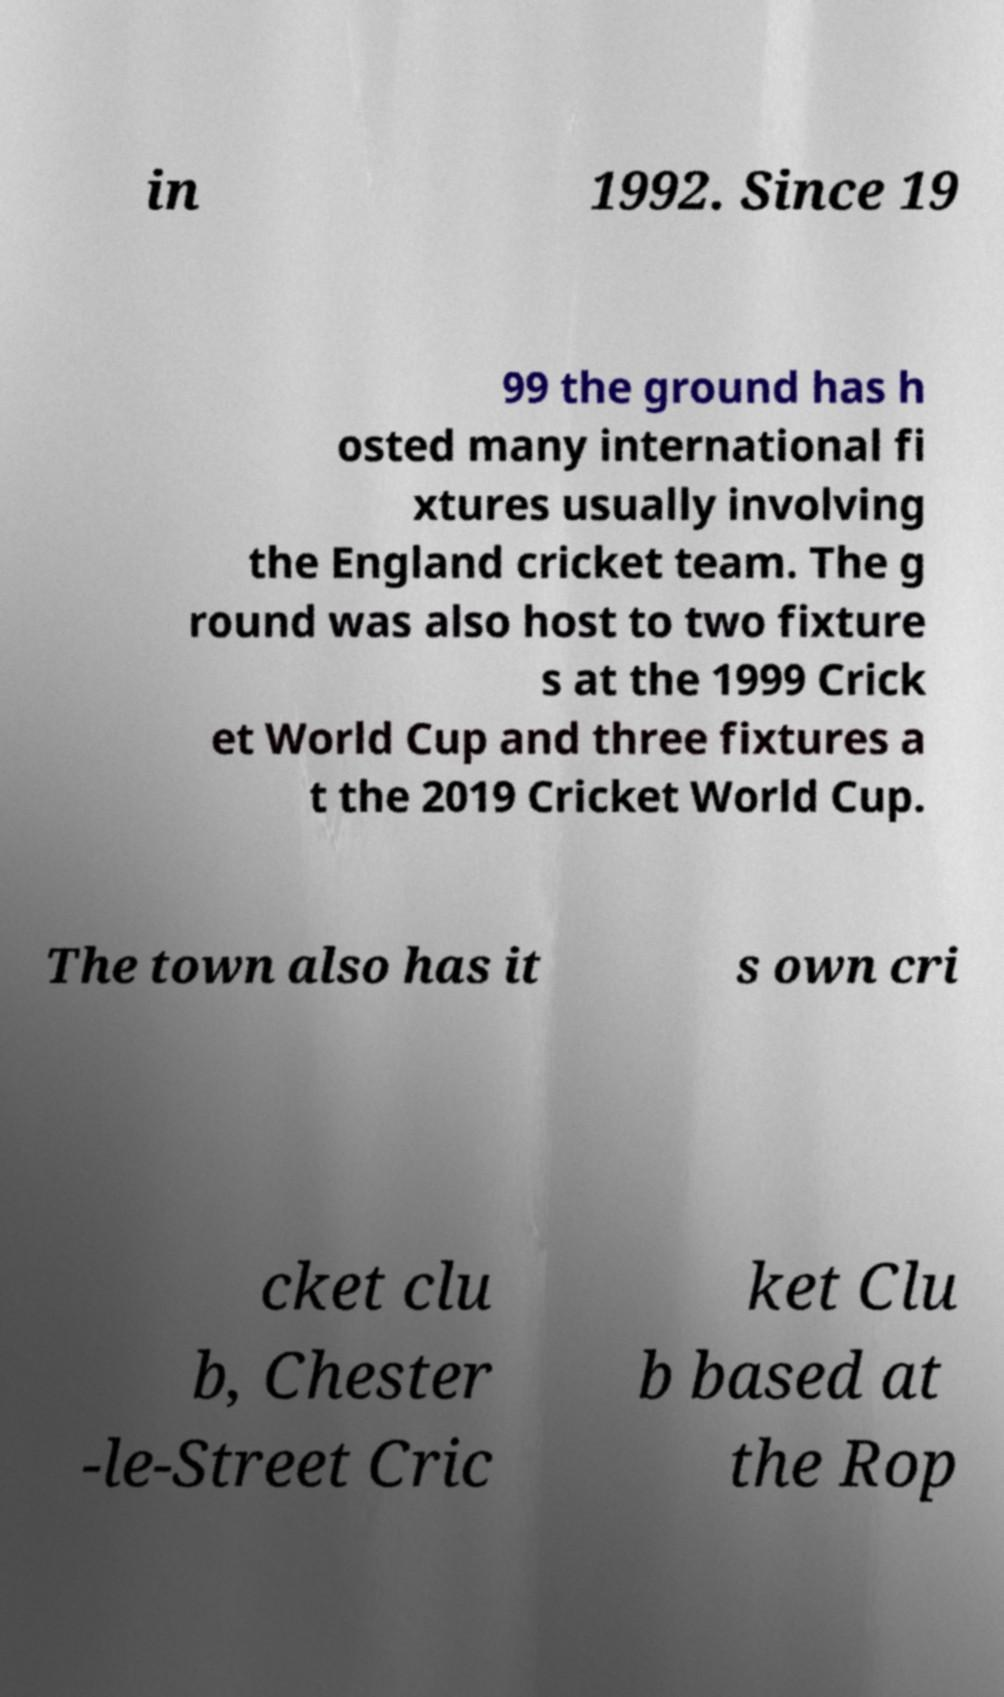There's text embedded in this image that I need extracted. Can you transcribe it verbatim? in 1992. Since 19 99 the ground has h osted many international fi xtures usually involving the England cricket team. The g round was also host to two fixture s at the 1999 Crick et World Cup and three fixtures a t the 2019 Cricket World Cup. The town also has it s own cri cket clu b, Chester -le-Street Cric ket Clu b based at the Rop 